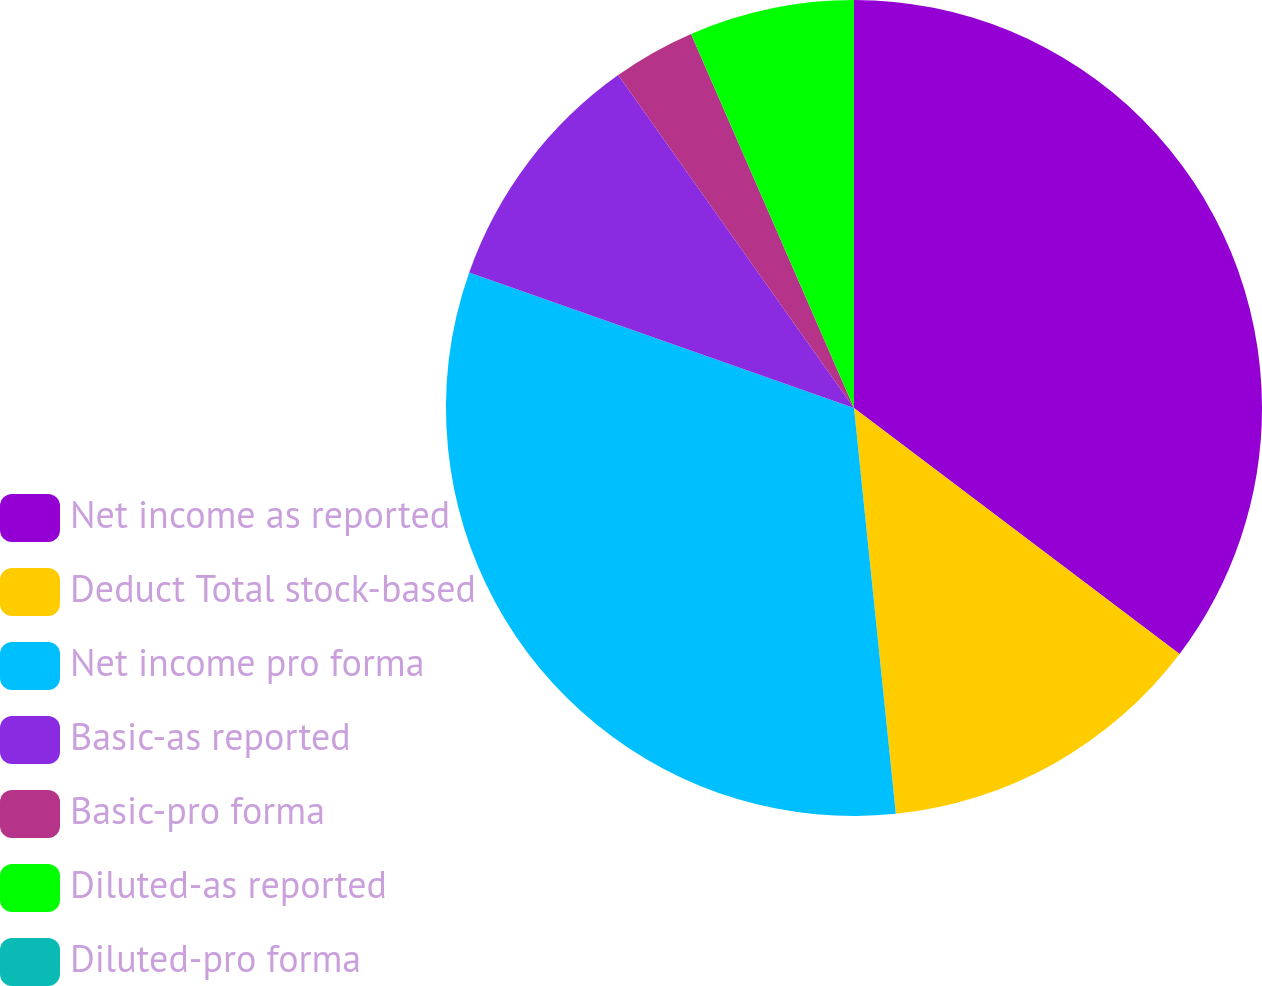Convert chart to OTSL. <chart><loc_0><loc_0><loc_500><loc_500><pie_chart><fcel>Net income as reported<fcel>Deduct Total stock-based<fcel>Net income pro forma<fcel>Basic-as reported<fcel>Basic-pro forma<fcel>Diluted-as reported<fcel>Diluted-pro forma<nl><fcel>35.3%<fcel>13.07%<fcel>32.03%<fcel>9.8%<fcel>3.27%<fcel>6.54%<fcel>0.0%<nl></chart> 